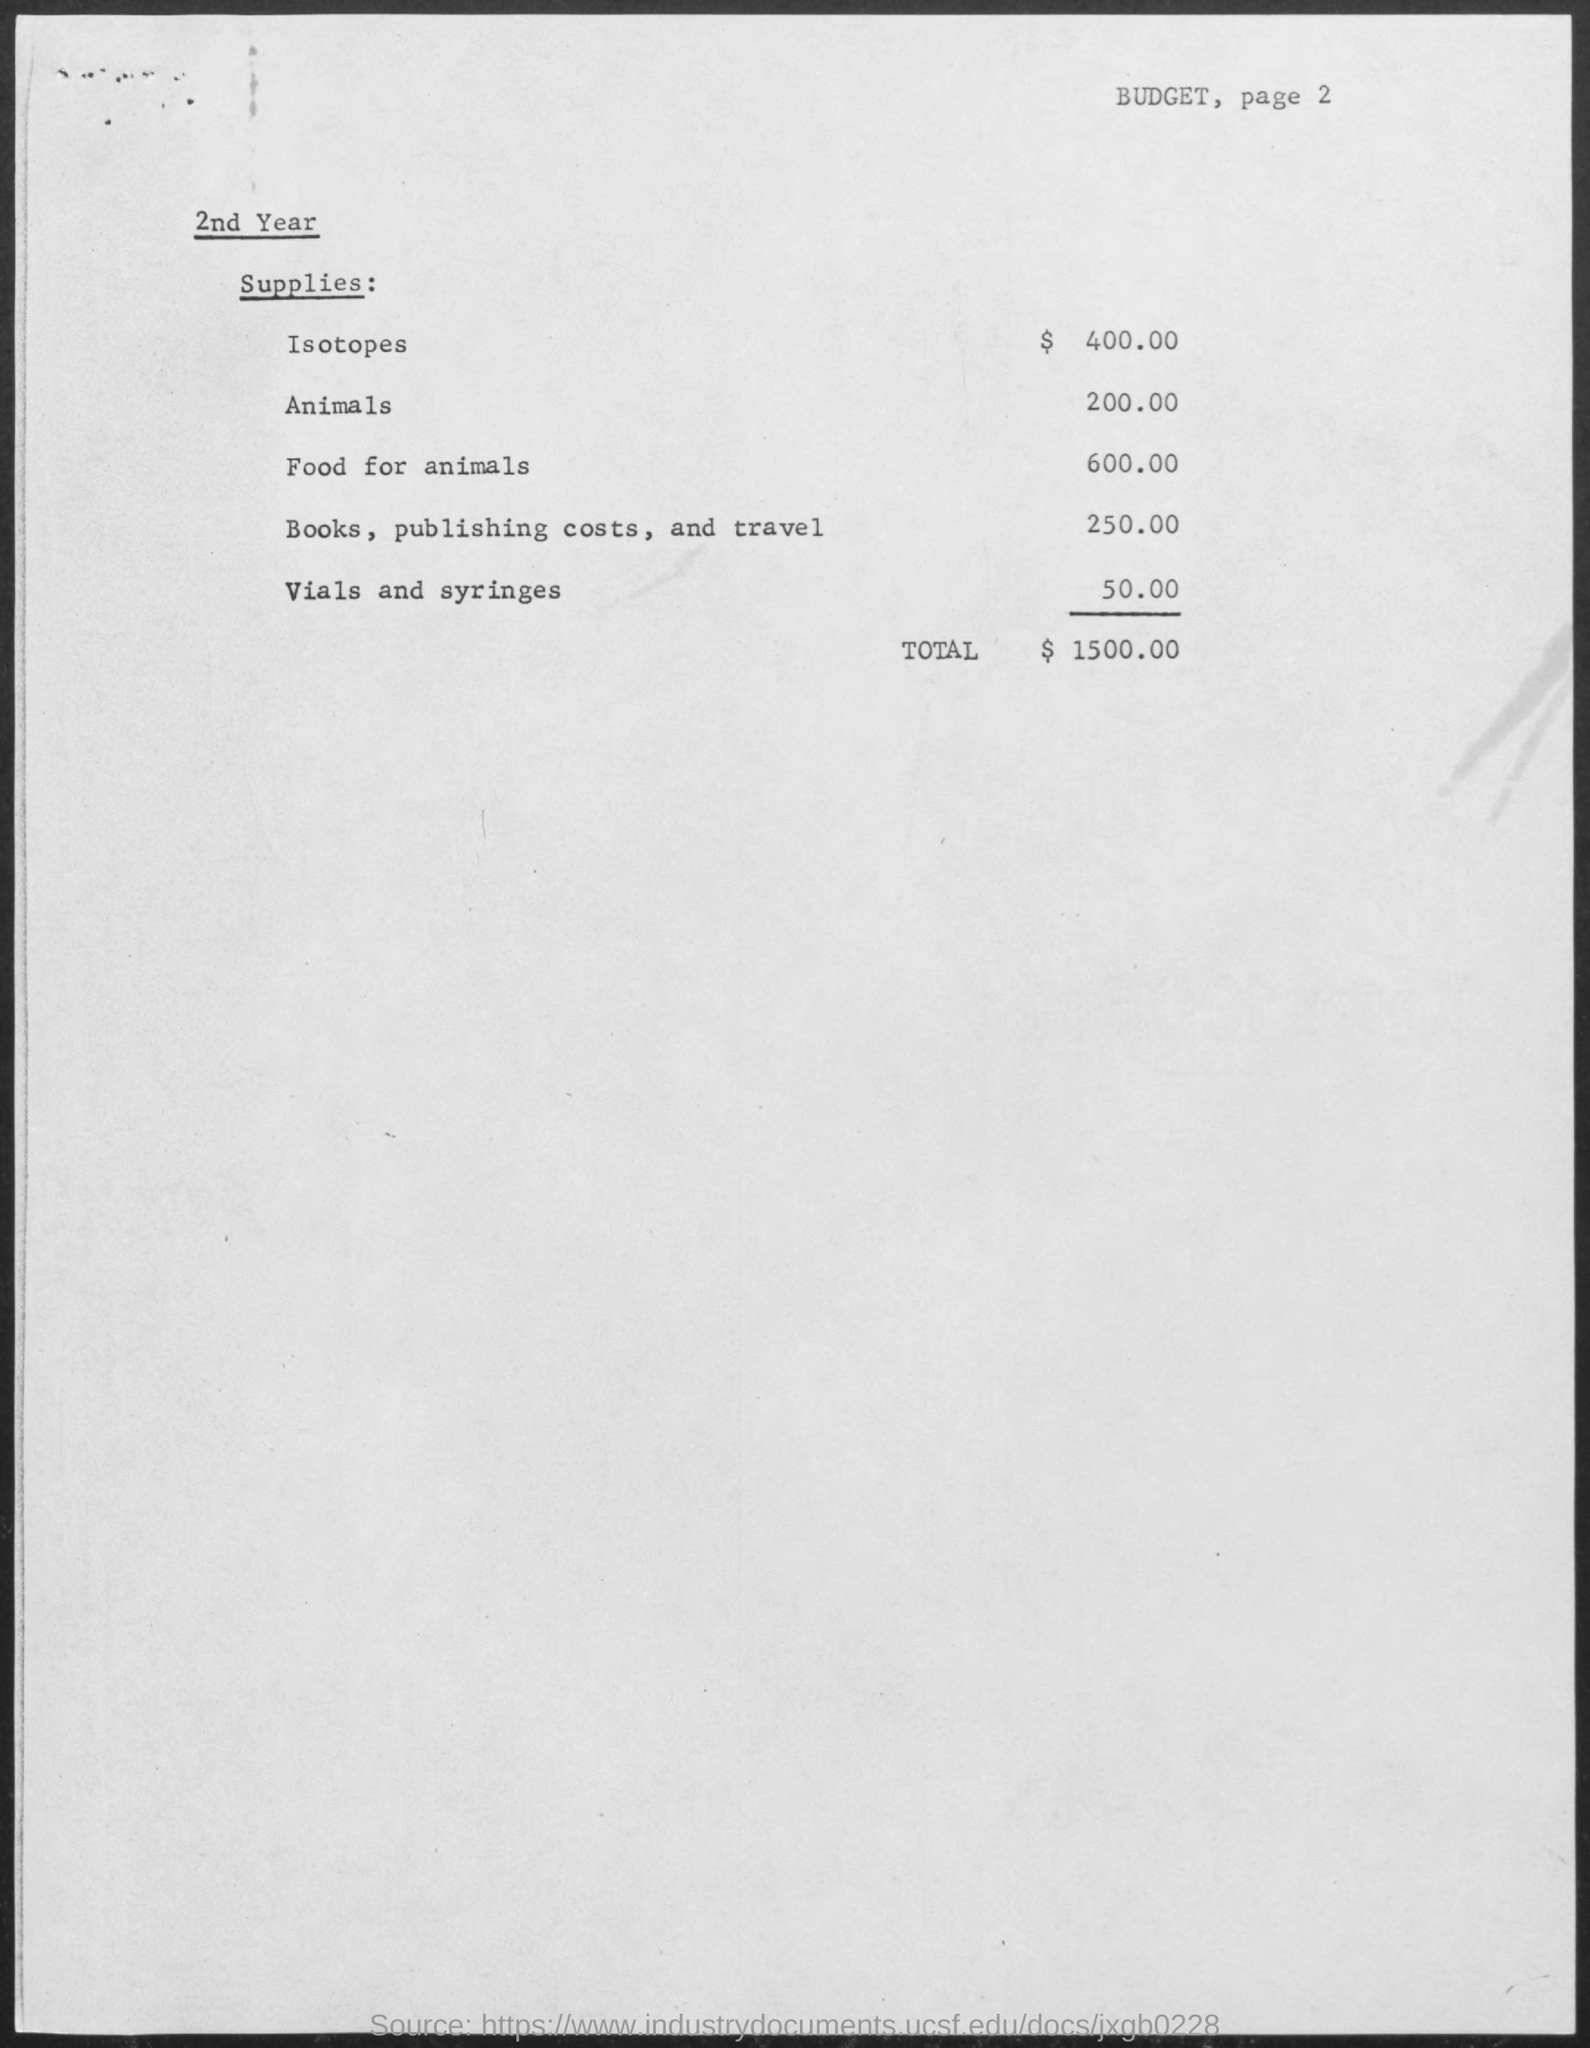What is the budget mentioned for isotopes ?
Provide a short and direct response. $ 400.00. What is the budget mentioned for animals ?
Offer a terse response. 200.00. What is the budget mentioned for food for animals ?
Ensure brevity in your answer.  600.00. What is the budget mentioned for books, publishing costs and travel ?
Your answer should be compact. 250.00. What is the budget mentioned for vials and syringes ?
Ensure brevity in your answer.  50.00. What is the total budget mentioned ?
Give a very brief answer. $ 1500.00. 